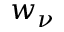<formula> <loc_0><loc_0><loc_500><loc_500>w _ { \nu }</formula> 